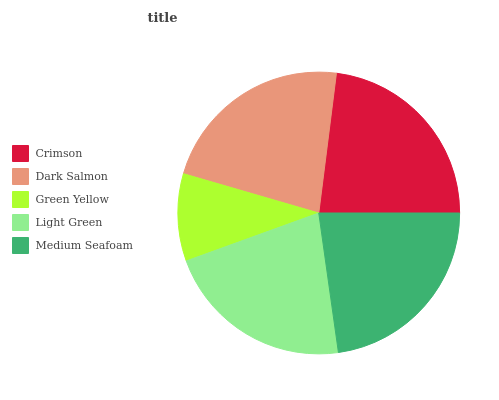Is Green Yellow the minimum?
Answer yes or no. Yes. Is Crimson the maximum?
Answer yes or no. Yes. Is Dark Salmon the minimum?
Answer yes or no. No. Is Dark Salmon the maximum?
Answer yes or no. No. Is Crimson greater than Dark Salmon?
Answer yes or no. Yes. Is Dark Salmon less than Crimson?
Answer yes or no. Yes. Is Dark Salmon greater than Crimson?
Answer yes or no. No. Is Crimson less than Dark Salmon?
Answer yes or no. No. Is Dark Salmon the high median?
Answer yes or no. Yes. Is Dark Salmon the low median?
Answer yes or no. Yes. Is Green Yellow the high median?
Answer yes or no. No. Is Light Green the low median?
Answer yes or no. No. 